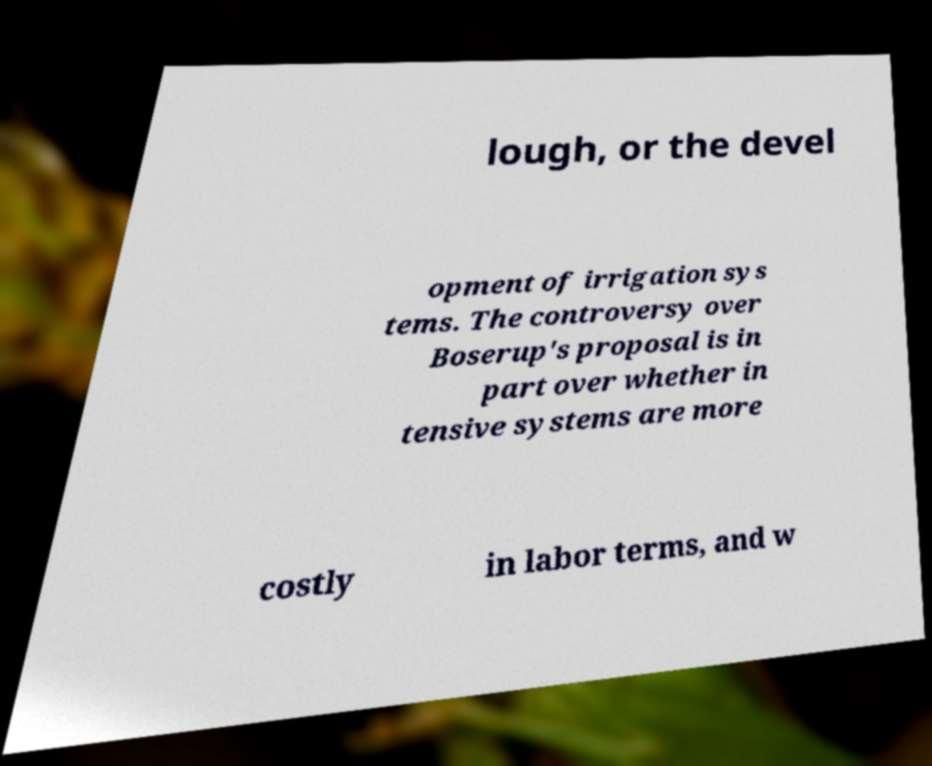For documentation purposes, I need the text within this image transcribed. Could you provide that? lough, or the devel opment of irrigation sys tems. The controversy over Boserup's proposal is in part over whether in tensive systems are more costly in labor terms, and w 